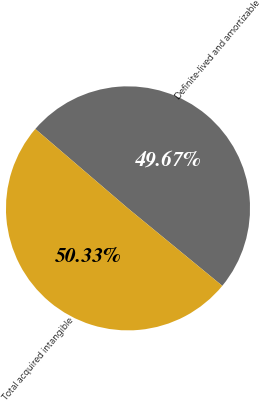Convert chart. <chart><loc_0><loc_0><loc_500><loc_500><pie_chart><fcel>Definite-lived and amortizable<fcel>Total acquired intangible<nl><fcel>49.67%<fcel>50.33%<nl></chart> 